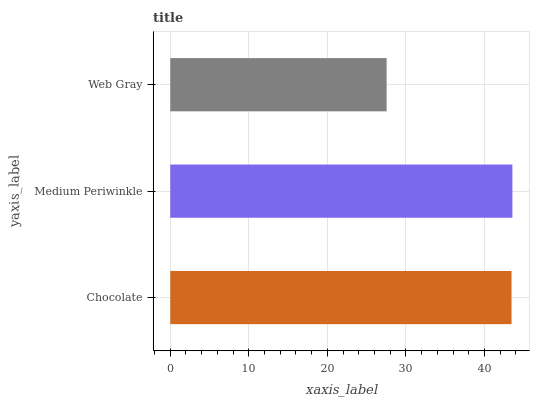Is Web Gray the minimum?
Answer yes or no. Yes. Is Medium Periwinkle the maximum?
Answer yes or no. Yes. Is Medium Periwinkle the minimum?
Answer yes or no. No. Is Web Gray the maximum?
Answer yes or no. No. Is Medium Periwinkle greater than Web Gray?
Answer yes or no. Yes. Is Web Gray less than Medium Periwinkle?
Answer yes or no. Yes. Is Web Gray greater than Medium Periwinkle?
Answer yes or no. No. Is Medium Periwinkle less than Web Gray?
Answer yes or no. No. Is Chocolate the high median?
Answer yes or no. Yes. Is Chocolate the low median?
Answer yes or no. Yes. Is Medium Periwinkle the high median?
Answer yes or no. No. Is Web Gray the low median?
Answer yes or no. No. 